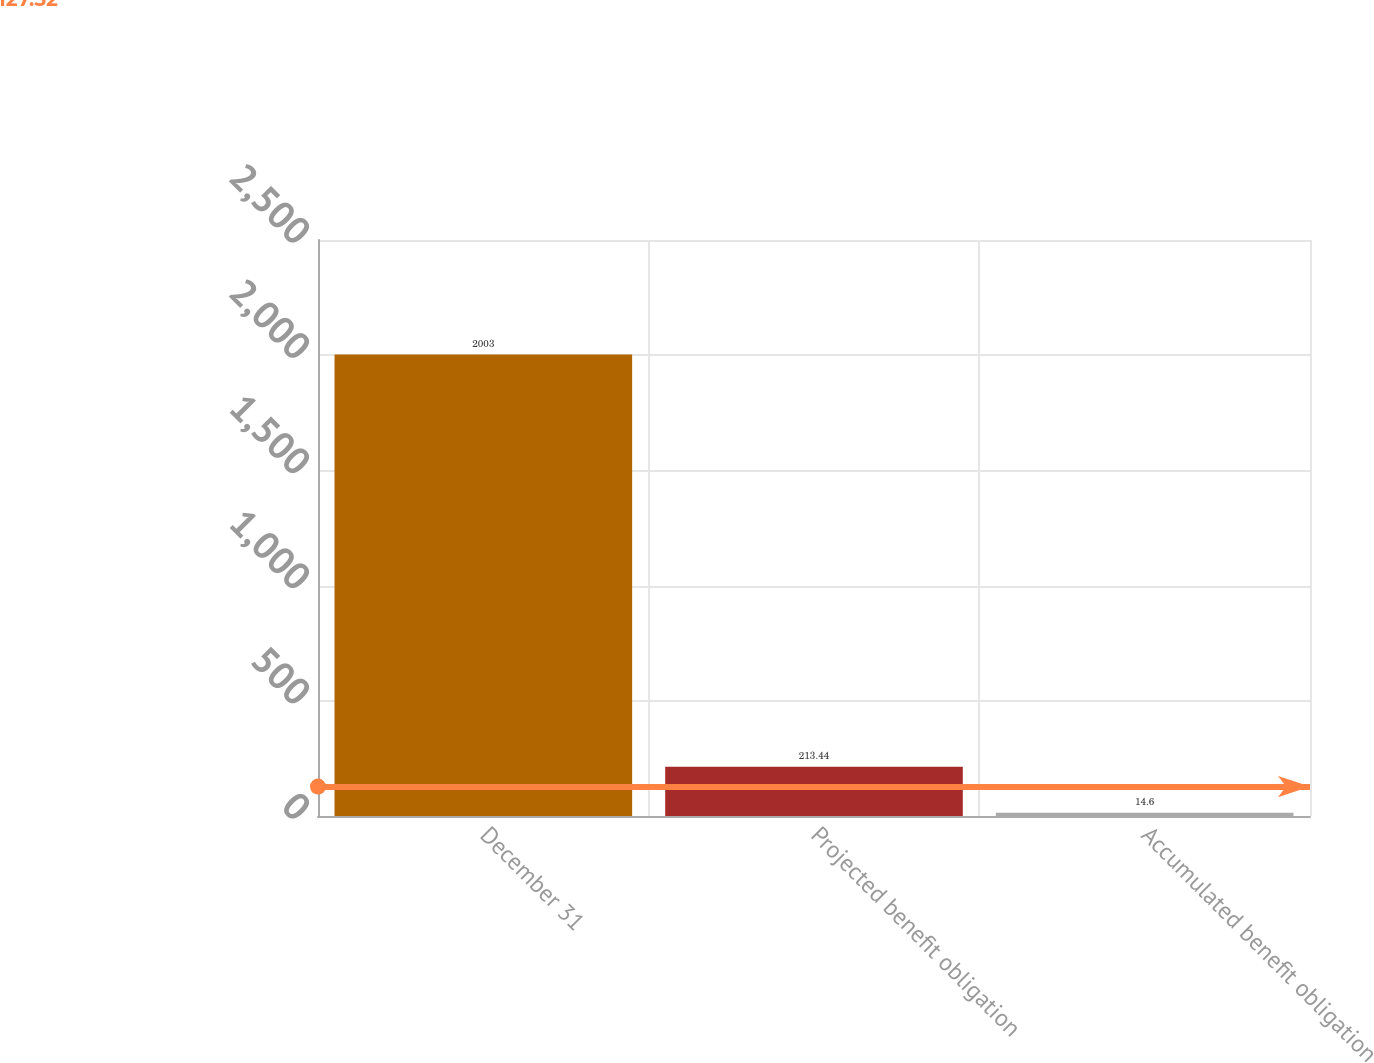Convert chart. <chart><loc_0><loc_0><loc_500><loc_500><bar_chart><fcel>December 31<fcel>Projected benefit obligation<fcel>Accumulated benefit obligation<nl><fcel>2003<fcel>213.44<fcel>14.6<nl></chart> 